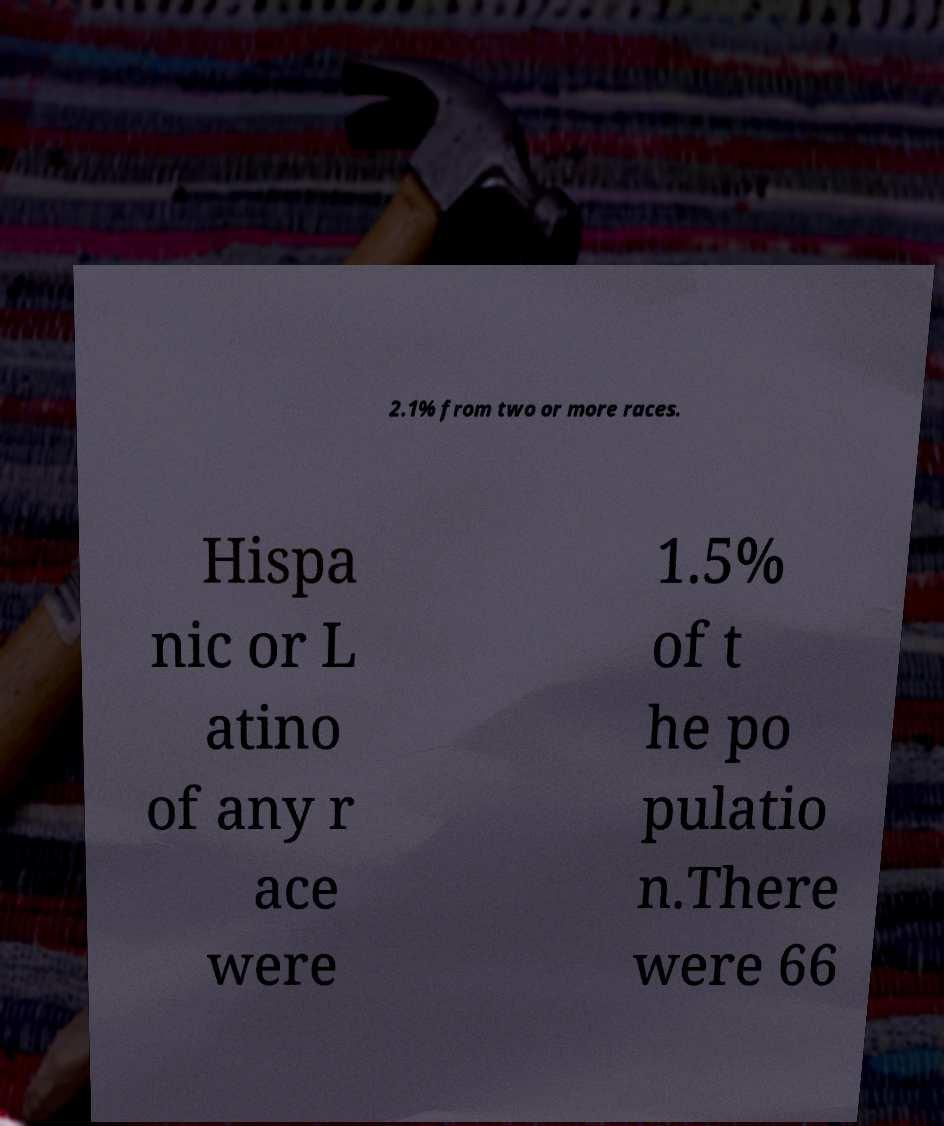For documentation purposes, I need the text within this image transcribed. Could you provide that? 2.1% from two or more races. Hispa nic or L atino of any r ace were 1.5% of t he po pulatio n.There were 66 